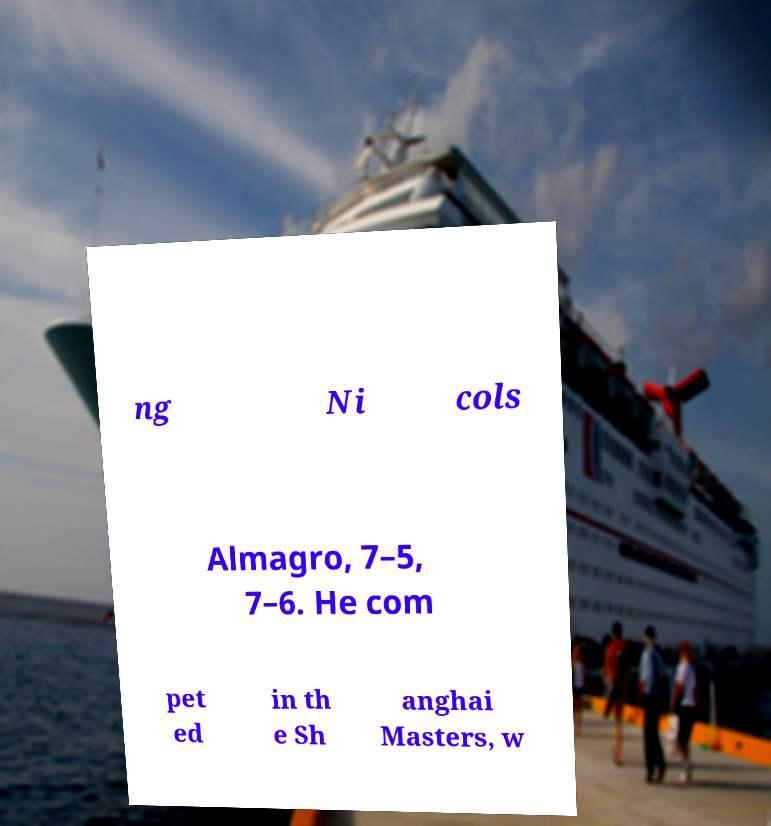There's text embedded in this image that I need extracted. Can you transcribe it verbatim? ng Ni cols Almagro, 7–5, 7–6. He com pet ed in th e Sh anghai Masters, w 